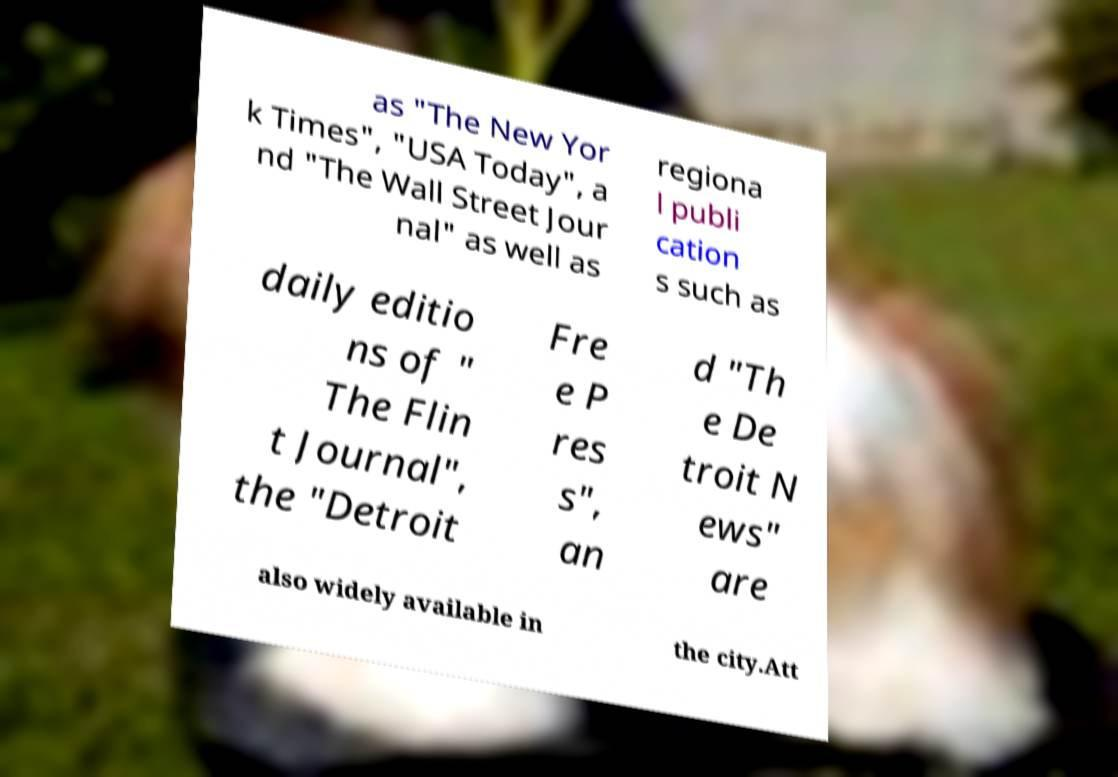Can you accurately transcribe the text from the provided image for me? as "The New Yor k Times", "USA Today", a nd "The Wall Street Jour nal" as well as regiona l publi cation s such as daily editio ns of " The Flin t Journal", the "Detroit Fre e P res s", an d "Th e De troit N ews" are also widely available in the city.Att 